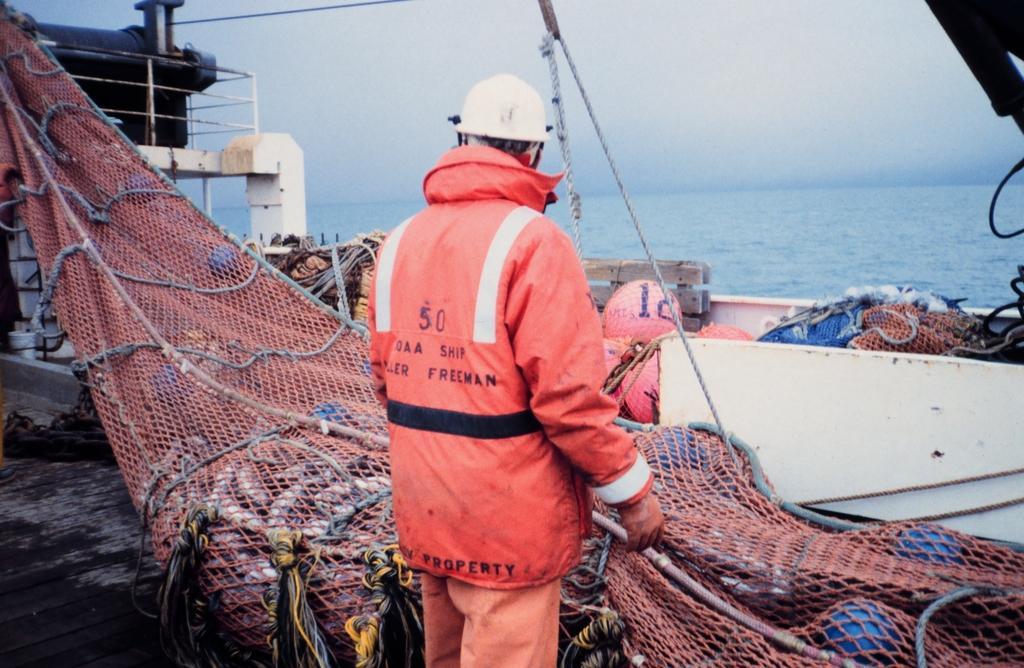Could you give a brief overview of what you see in this image? In this picture there is man who is standing in the center of the image, in a ship, there is a big fishing net in front of him and there are other fishing nets in front of him and there are ropes at the top side of the image and there is water in the background area of the image. 